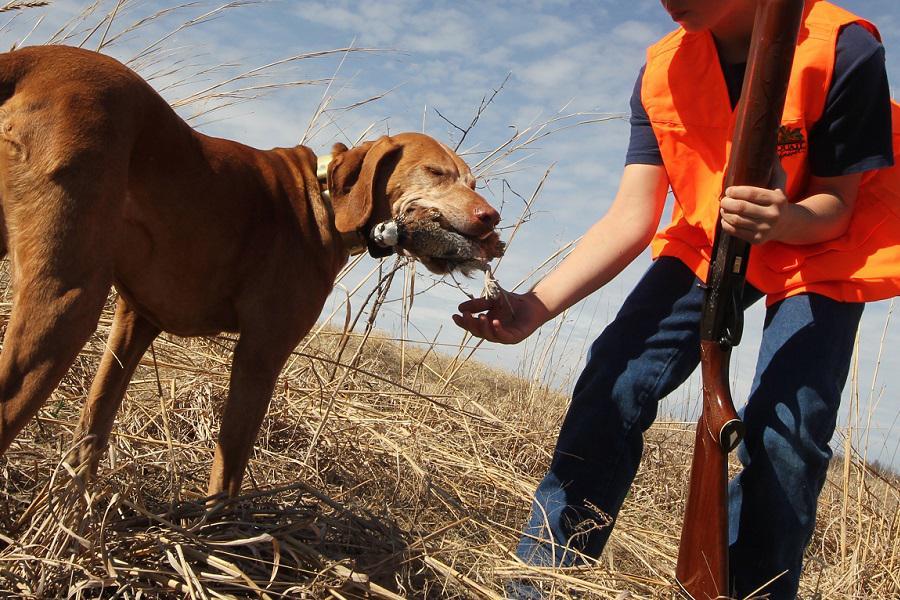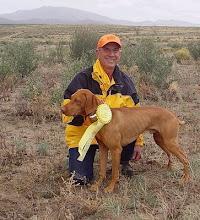The first image is the image on the left, the second image is the image on the right. For the images shown, is this caption "Nine or more mammals are present." true? Answer yes or no. No. The first image is the image on the left, the second image is the image on the right. Given the left and right images, does the statement "In one of the images hunters posing with their guns and prey." hold true? Answer yes or no. No. 